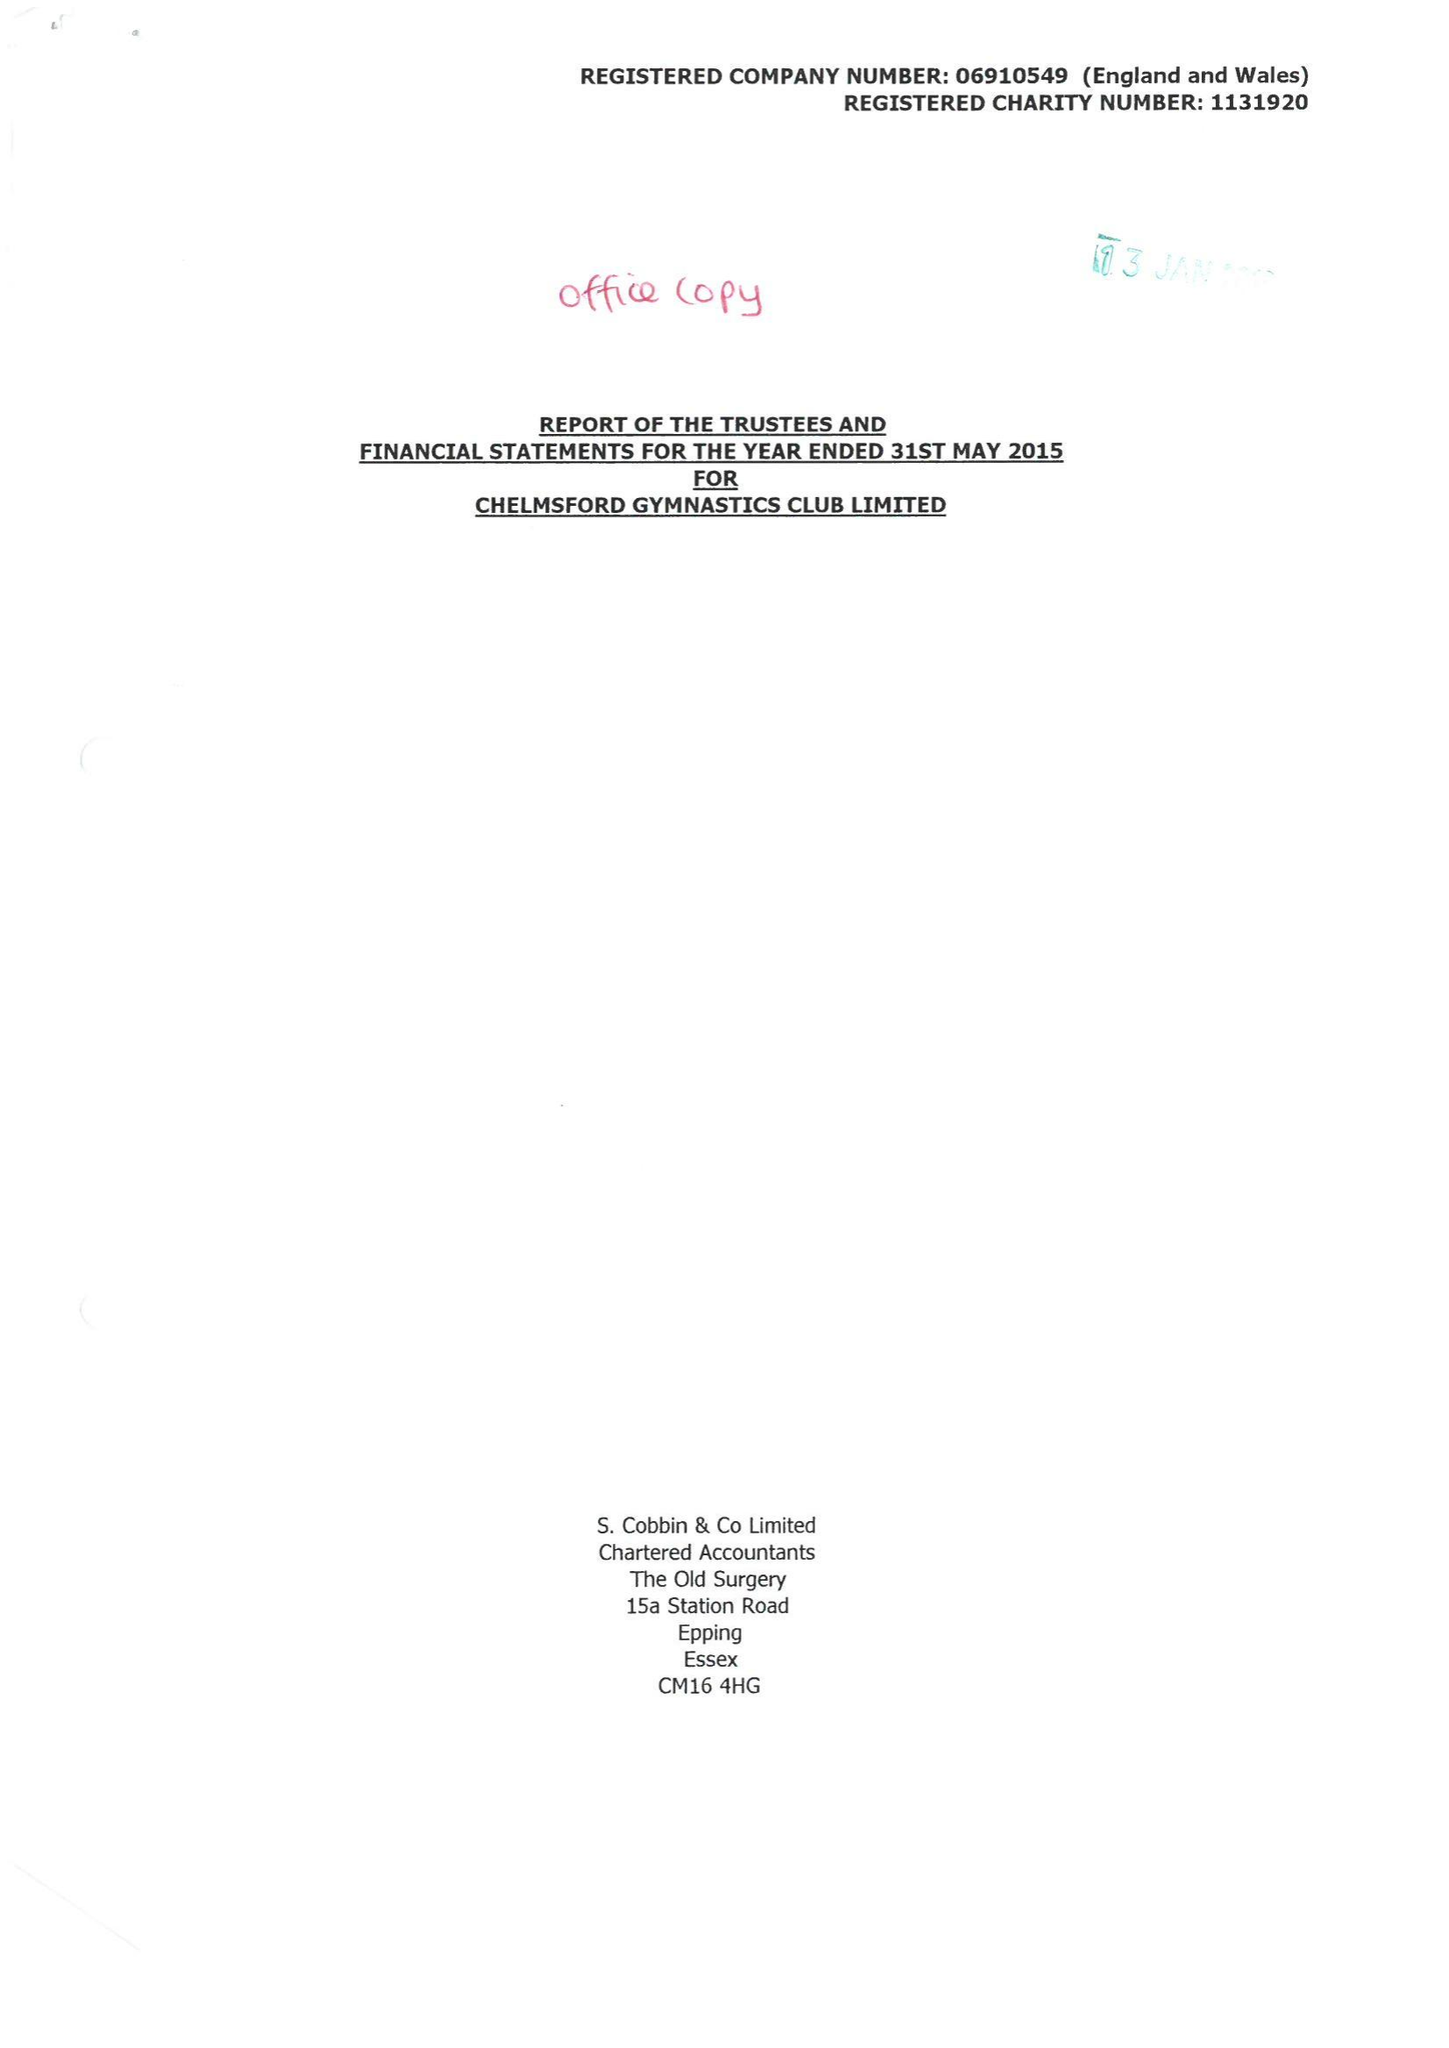What is the value for the spending_annually_in_british_pounds?
Answer the question using a single word or phrase. 358833.00 